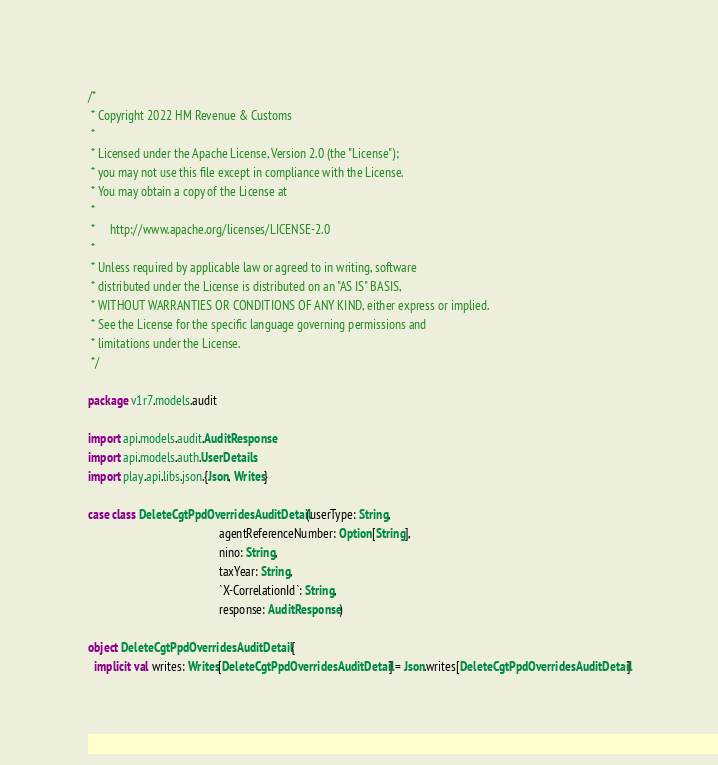<code> <loc_0><loc_0><loc_500><loc_500><_Scala_>/*
 * Copyright 2022 HM Revenue & Customs
 *
 * Licensed under the Apache License, Version 2.0 (the "License");
 * you may not use this file except in compliance with the License.
 * You may obtain a copy of the License at
 *
 *     http://www.apache.org/licenses/LICENSE-2.0
 *
 * Unless required by applicable law or agreed to in writing, software
 * distributed under the License is distributed on an "AS IS" BASIS,
 * WITHOUT WARRANTIES OR CONDITIONS OF ANY KIND, either express or implied.
 * See the License for the specific language governing permissions and
 * limitations under the License.
 */

package v1r7.models.audit

import api.models.audit.AuditResponse
import api.models.auth.UserDetails
import play.api.libs.json.{Json, Writes}

case class DeleteCgtPpdOverridesAuditDetail(userType: String,
                                            agentReferenceNumber: Option[String],
                                            nino: String,
                                            taxYear: String,
                                            `X-CorrelationId`: String,
                                            response: AuditResponse)

object DeleteCgtPpdOverridesAuditDetail {
  implicit val writes: Writes[DeleteCgtPpdOverridesAuditDetail] = Json.writes[DeleteCgtPpdOverridesAuditDetail]
</code> 